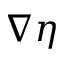<formula> <loc_0><loc_0><loc_500><loc_500>\nabla \eta</formula> 